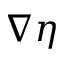<formula> <loc_0><loc_0><loc_500><loc_500>\nabla \eta</formula> 